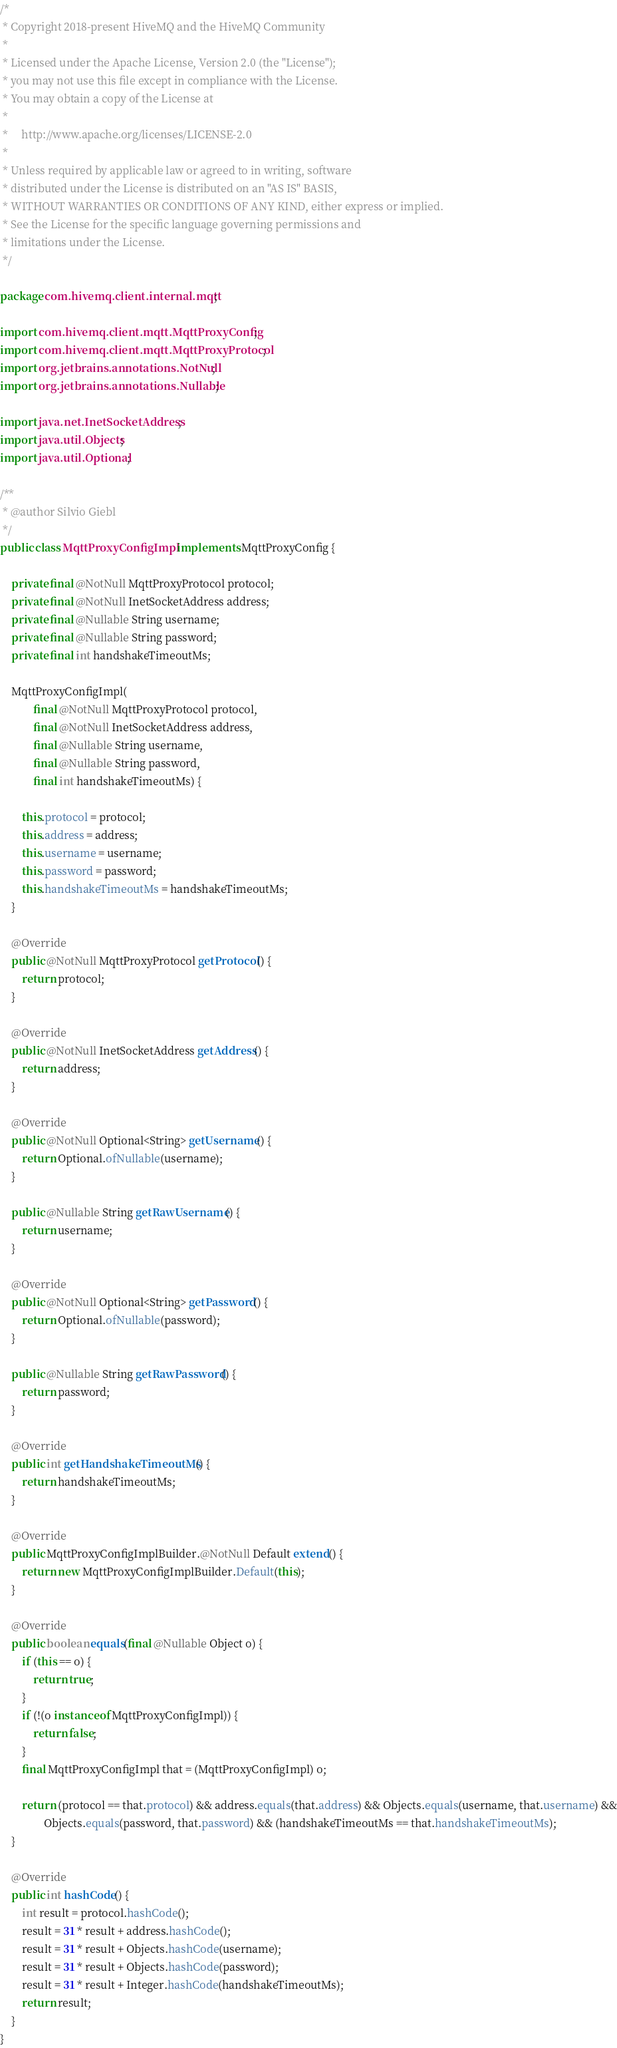Convert code to text. <code><loc_0><loc_0><loc_500><loc_500><_Java_>/*
 * Copyright 2018-present HiveMQ and the HiveMQ Community
 *
 * Licensed under the Apache License, Version 2.0 (the "License");
 * you may not use this file except in compliance with the License.
 * You may obtain a copy of the License at
 *
 *     http://www.apache.org/licenses/LICENSE-2.0
 *
 * Unless required by applicable law or agreed to in writing, software
 * distributed under the License is distributed on an "AS IS" BASIS,
 * WITHOUT WARRANTIES OR CONDITIONS OF ANY KIND, either express or implied.
 * See the License for the specific language governing permissions and
 * limitations under the License.
 */

package com.hivemq.client.internal.mqtt;

import com.hivemq.client.mqtt.MqttProxyConfig;
import com.hivemq.client.mqtt.MqttProxyProtocol;
import org.jetbrains.annotations.NotNull;
import org.jetbrains.annotations.Nullable;

import java.net.InetSocketAddress;
import java.util.Objects;
import java.util.Optional;

/**
 * @author Silvio Giebl
 */
public class MqttProxyConfigImpl implements MqttProxyConfig {

    private final @NotNull MqttProxyProtocol protocol;
    private final @NotNull InetSocketAddress address;
    private final @Nullable String username;
    private final @Nullable String password;
    private final int handshakeTimeoutMs;

    MqttProxyConfigImpl(
            final @NotNull MqttProxyProtocol protocol,
            final @NotNull InetSocketAddress address,
            final @Nullable String username,
            final @Nullable String password,
            final int handshakeTimeoutMs) {

        this.protocol = protocol;
        this.address = address;
        this.username = username;
        this.password = password;
        this.handshakeTimeoutMs = handshakeTimeoutMs;
    }

    @Override
    public @NotNull MqttProxyProtocol getProtocol() {
        return protocol;
    }

    @Override
    public @NotNull InetSocketAddress getAddress() {
        return address;
    }

    @Override
    public @NotNull Optional<String> getUsername() {
        return Optional.ofNullable(username);
    }

    public @Nullable String getRawUsername() {
        return username;
    }

    @Override
    public @NotNull Optional<String> getPassword() {
        return Optional.ofNullable(password);
    }

    public @Nullable String getRawPassword() {
        return password;
    }

    @Override
    public int getHandshakeTimeoutMs() {
        return handshakeTimeoutMs;
    }

    @Override
    public MqttProxyConfigImplBuilder.@NotNull Default extend() {
        return new MqttProxyConfigImplBuilder.Default(this);
    }

    @Override
    public boolean equals(final @Nullable Object o) {
        if (this == o) {
            return true;
        }
        if (!(o instanceof MqttProxyConfigImpl)) {
            return false;
        }
        final MqttProxyConfigImpl that = (MqttProxyConfigImpl) o;

        return (protocol == that.protocol) && address.equals(that.address) && Objects.equals(username, that.username) &&
                Objects.equals(password, that.password) && (handshakeTimeoutMs == that.handshakeTimeoutMs);
    }

    @Override
    public int hashCode() {
        int result = protocol.hashCode();
        result = 31 * result + address.hashCode();
        result = 31 * result + Objects.hashCode(username);
        result = 31 * result + Objects.hashCode(password);
        result = 31 * result + Integer.hashCode(handshakeTimeoutMs);
        return result;
    }
}
</code> 